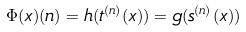Convert formula to latex. <formula><loc_0><loc_0><loc_500><loc_500>\Phi ( x ) ( n ) = h ( t ^ { ( n ) } ( x ) ) = g ( s ^ { ( n ) } ( x ) )</formula> 